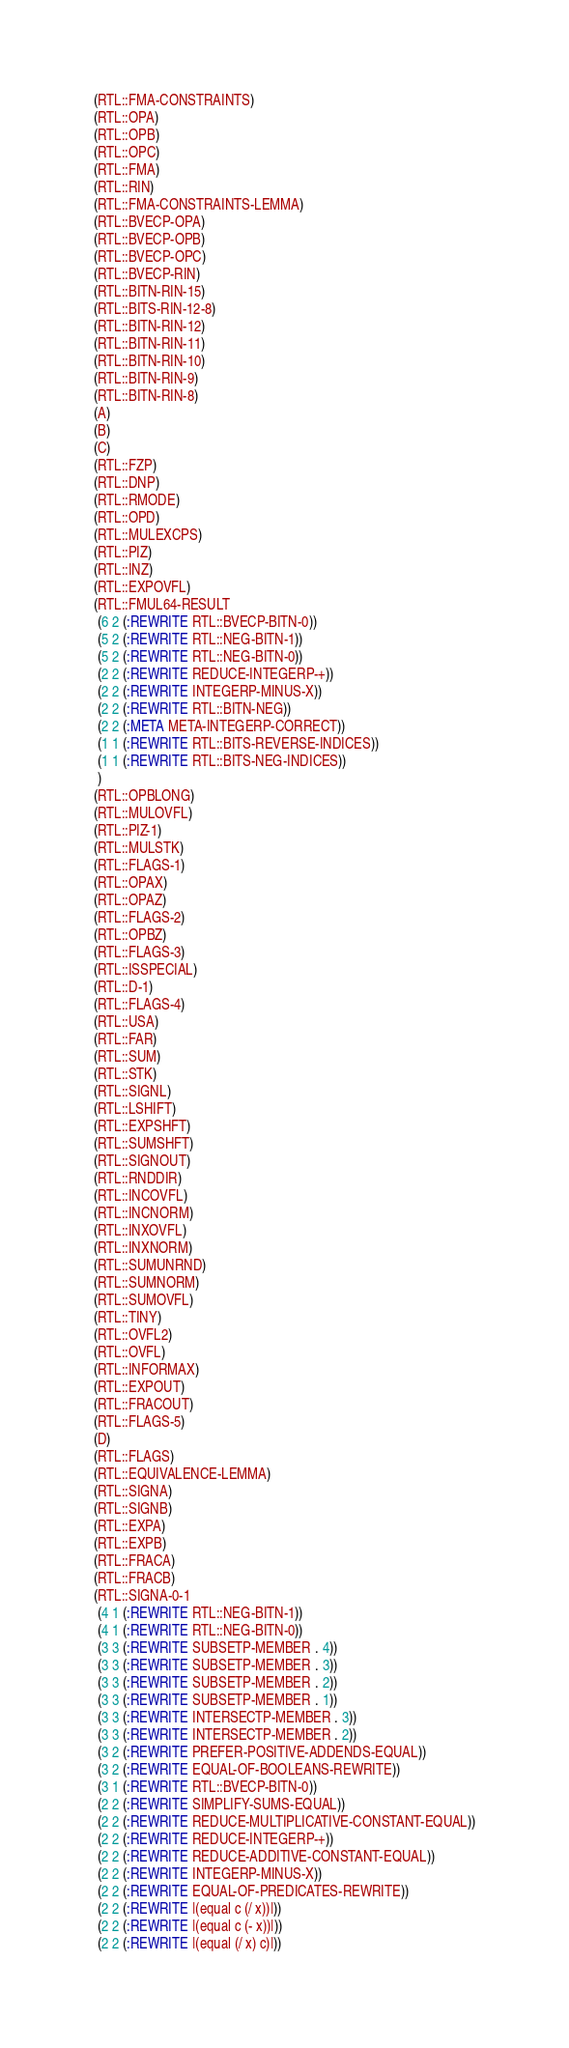<code> <loc_0><loc_0><loc_500><loc_500><_Lisp_>(RTL::FMA-CONSTRAINTS)
(RTL::OPA)
(RTL::OPB)
(RTL::OPC)
(RTL::FMA)
(RTL::RIN)
(RTL::FMA-CONSTRAINTS-LEMMA)
(RTL::BVECP-OPA)
(RTL::BVECP-OPB)
(RTL::BVECP-OPC)
(RTL::BVECP-RIN)
(RTL::BITN-RIN-15)
(RTL::BITS-RIN-12-8)
(RTL::BITN-RIN-12)
(RTL::BITN-RIN-11)
(RTL::BITN-RIN-10)
(RTL::BITN-RIN-9)
(RTL::BITN-RIN-8)
(A)
(B)
(C)
(RTL::FZP)
(RTL::DNP)
(RTL::RMODE)
(RTL::OPD)
(RTL::MULEXCPS)
(RTL::PIZ)
(RTL::INZ)
(RTL::EXPOVFL)
(RTL::FMUL64-RESULT
 (6 2 (:REWRITE RTL::BVECP-BITN-0))
 (5 2 (:REWRITE RTL::NEG-BITN-1))
 (5 2 (:REWRITE RTL::NEG-BITN-0))
 (2 2 (:REWRITE REDUCE-INTEGERP-+))
 (2 2 (:REWRITE INTEGERP-MINUS-X))
 (2 2 (:REWRITE RTL::BITN-NEG))
 (2 2 (:META META-INTEGERP-CORRECT))
 (1 1 (:REWRITE RTL::BITS-REVERSE-INDICES))
 (1 1 (:REWRITE RTL::BITS-NEG-INDICES))
 )
(RTL::OPBLONG)
(RTL::MULOVFL)
(RTL::PIZ-1)
(RTL::MULSTK)
(RTL::FLAGS-1)
(RTL::OPAX)
(RTL::OPAZ)
(RTL::FLAGS-2)
(RTL::OPBZ)
(RTL::FLAGS-3)
(RTL::ISSPECIAL)
(RTL::D-1)
(RTL::FLAGS-4)
(RTL::USA)
(RTL::FAR)
(RTL::SUM)
(RTL::STK)
(RTL::SIGNL)
(RTL::LSHIFT)
(RTL::EXPSHFT)
(RTL::SUMSHFT)
(RTL::SIGNOUT)
(RTL::RNDDIR)
(RTL::INCOVFL)
(RTL::INCNORM)
(RTL::INXOVFL)
(RTL::INXNORM)
(RTL::SUMUNRND)
(RTL::SUMNORM)
(RTL::SUMOVFL)
(RTL::TINY)
(RTL::OVFL2)
(RTL::OVFL)
(RTL::INFORMAX)
(RTL::EXPOUT)
(RTL::FRACOUT)
(RTL::FLAGS-5)
(D)
(RTL::FLAGS)
(RTL::EQUIVALENCE-LEMMA)
(RTL::SIGNA)
(RTL::SIGNB)
(RTL::EXPA)
(RTL::EXPB)
(RTL::FRACA)
(RTL::FRACB)
(RTL::SIGNA-0-1
 (4 1 (:REWRITE RTL::NEG-BITN-1))
 (4 1 (:REWRITE RTL::NEG-BITN-0))
 (3 3 (:REWRITE SUBSETP-MEMBER . 4))
 (3 3 (:REWRITE SUBSETP-MEMBER . 3))
 (3 3 (:REWRITE SUBSETP-MEMBER . 2))
 (3 3 (:REWRITE SUBSETP-MEMBER . 1))
 (3 3 (:REWRITE INTERSECTP-MEMBER . 3))
 (3 3 (:REWRITE INTERSECTP-MEMBER . 2))
 (3 2 (:REWRITE PREFER-POSITIVE-ADDENDS-EQUAL))
 (3 2 (:REWRITE EQUAL-OF-BOOLEANS-REWRITE))
 (3 1 (:REWRITE RTL::BVECP-BITN-0))
 (2 2 (:REWRITE SIMPLIFY-SUMS-EQUAL))
 (2 2 (:REWRITE REDUCE-MULTIPLICATIVE-CONSTANT-EQUAL))
 (2 2 (:REWRITE REDUCE-INTEGERP-+))
 (2 2 (:REWRITE REDUCE-ADDITIVE-CONSTANT-EQUAL))
 (2 2 (:REWRITE INTEGERP-MINUS-X))
 (2 2 (:REWRITE EQUAL-OF-PREDICATES-REWRITE))
 (2 2 (:REWRITE |(equal c (/ x))|))
 (2 2 (:REWRITE |(equal c (- x))|))
 (2 2 (:REWRITE |(equal (/ x) c)|))</code> 